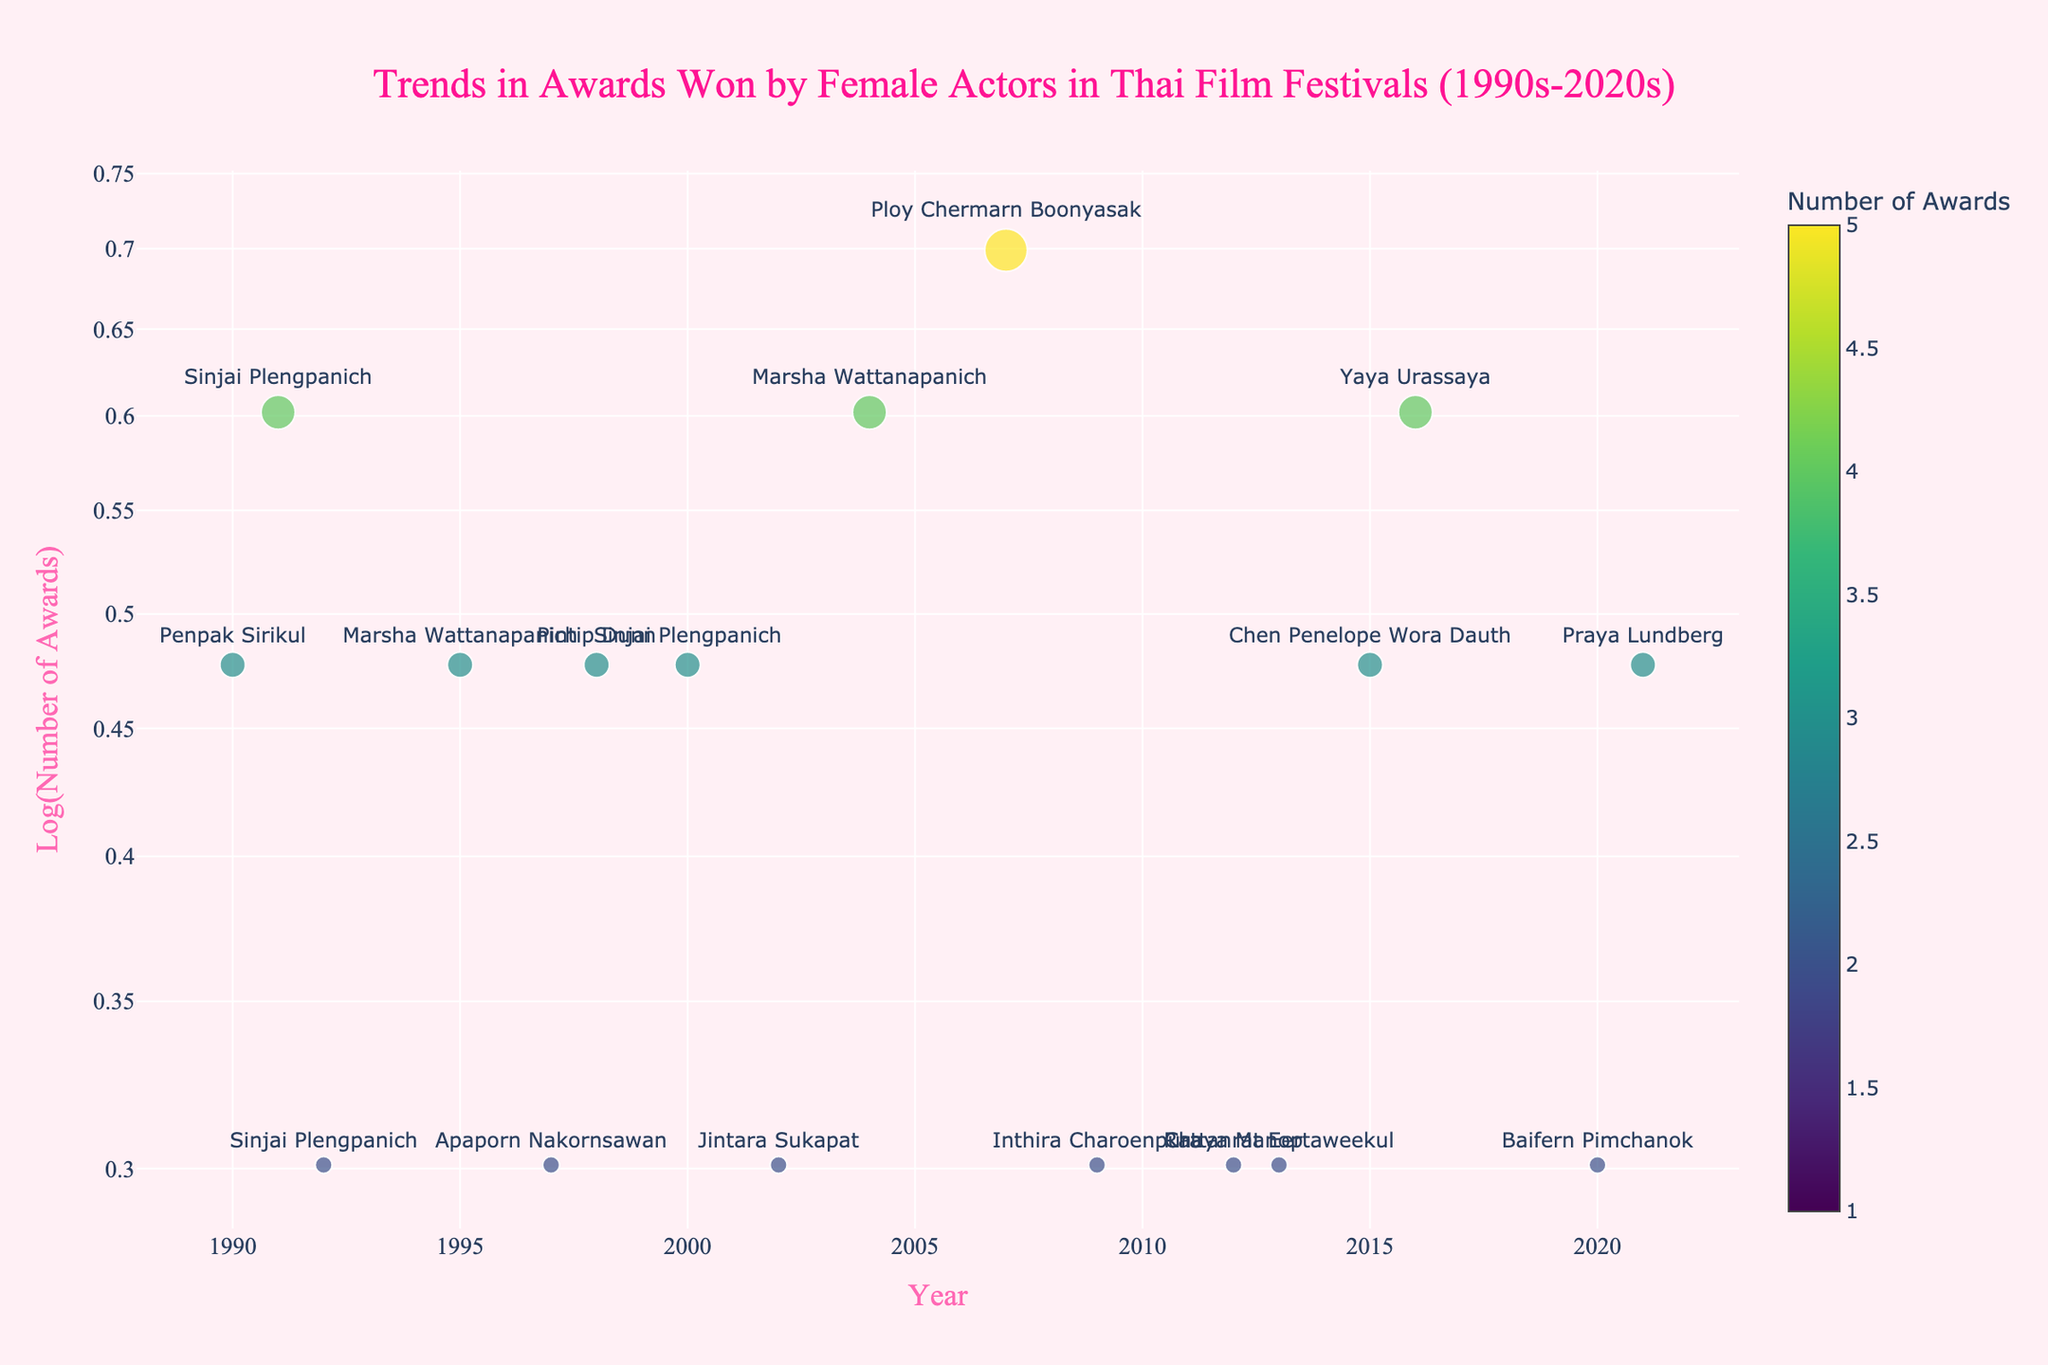what is the title of the plot? The title of the plot is centered at the top and indicates the theme of the data displayed, focusing on trends in awards won by female actors in Thai film festivals.
Answer: Trends in Awards Won by Female Actors in Thai Film Festivals (1990s-2020s) How many data points represent awards won in the 2020s? Look for the data points along the x-axis that fall within the years 2020 and beyond. Count the corresponding points.
Answer: 2 Which actress won the highest number of awards in a single year, and how many did she win? Look for the largest marker dot on the plot and hover over it to see the actress' name and the number of awards she won.
Answer: Ploy Chermarn Boonyasak, 5 What color represents a higher number of awards on the plot? The color gradient on the plot indicates number of awards, with a scale shown on the right-hand side. Identify which end of the color gradient (from light to dark) corresponds to the higher numbers.
Answer: Darker color Who won the most awards in 1995, and how many did she win? Find the data point on the x-axis corresponding to 1995 and refer to the marker size and hover text to determine the actress and the number of awards.
Answer: Marsha Wattanapanich, 3 What is the range of years represented in the plot? Look at the x-axis to identify the earliest and latest years shown, which will give the range of years.
Answer: 1990 to 2021 Is there a visible trend in the number of awards won by female actors over the years? Visually analyze the distribution and size of the markers over the timeline on the x-axis to identify any patterns or trends.
Answer: No clear trend How many actresses won exactly 3 awards? Count the number of markers that correspond to 3 awards, which can be identified by the size and hover text on the plot.
Answer: 5 Which year saw the lowest number of awards given to a female actor, and who was the actress? Identify the smallest marker on the plot and use the hover text to determine the corresponding year and actress.
Answer: 1993, Jintara Sukapat Do Bangkok Critics Assembly awards frequently appear throughout the years? Look at the overall distribution of markers labeled "Bangkok Critics Assembly" by examining the hover text associated with each year.
Answer: Yes 